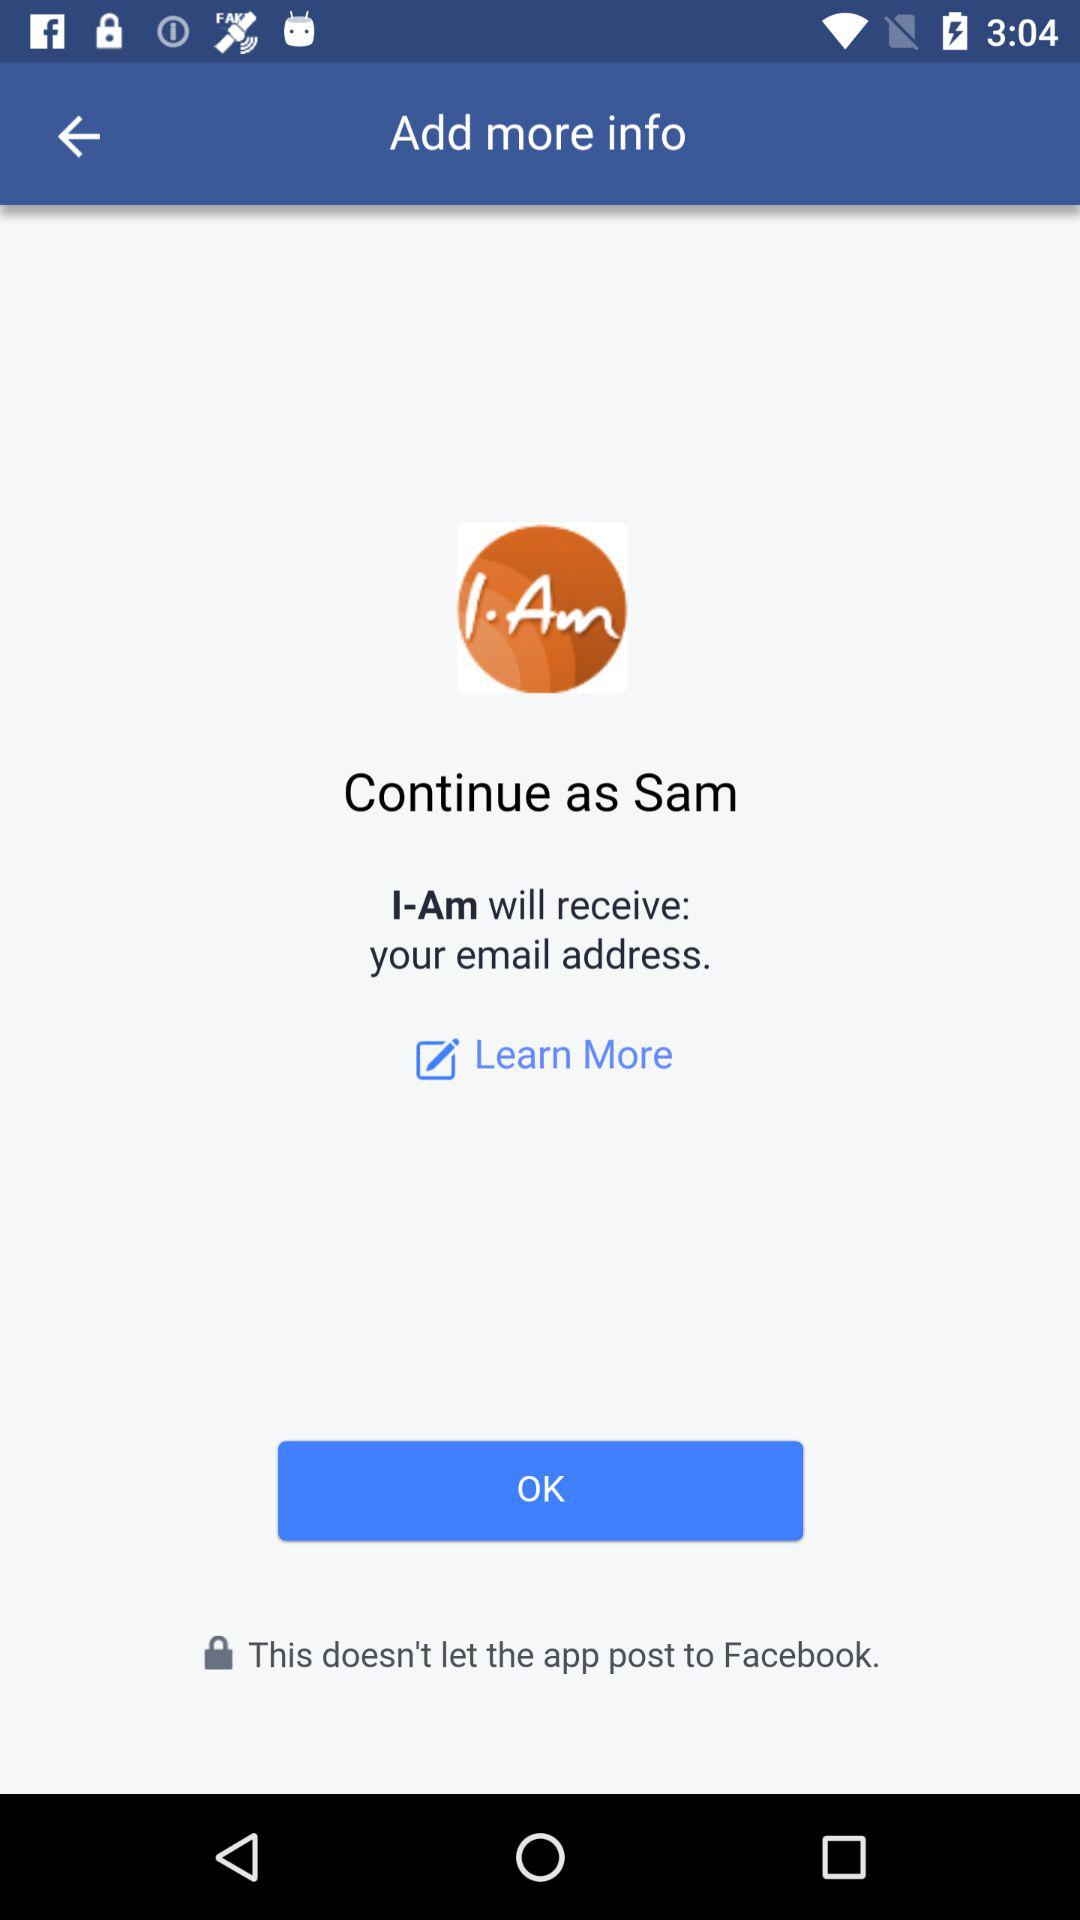What is the name of the user? The name of the user is Sam. 